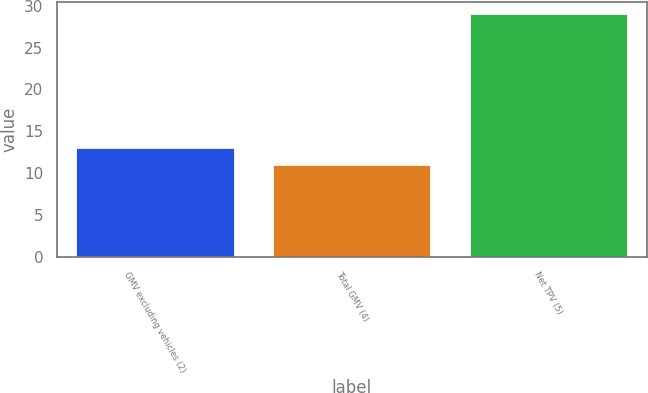Convert chart. <chart><loc_0><loc_0><loc_500><loc_500><bar_chart><fcel>GMV excluding vehicles (2)<fcel>Total GMV (4)<fcel>Net TPV (5)<nl><fcel>13<fcel>11<fcel>29<nl></chart> 